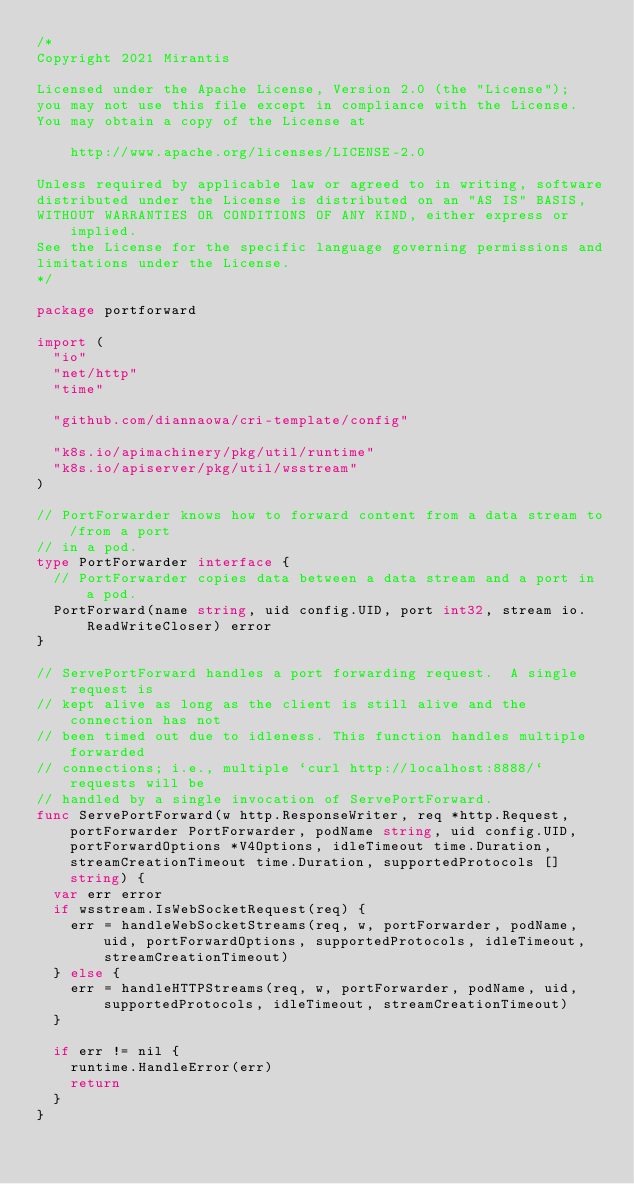Convert code to text. <code><loc_0><loc_0><loc_500><loc_500><_Go_>/*
Copyright 2021 Mirantis

Licensed under the Apache License, Version 2.0 (the "License");
you may not use this file except in compliance with the License.
You may obtain a copy of the License at

    http://www.apache.org/licenses/LICENSE-2.0

Unless required by applicable law or agreed to in writing, software
distributed under the License is distributed on an "AS IS" BASIS,
WITHOUT WARRANTIES OR CONDITIONS OF ANY KIND, either express or implied.
See the License for the specific language governing permissions and
limitations under the License.
*/

package portforward

import (
	"io"
	"net/http"
	"time"

	"github.com/diannaowa/cri-template/config"

	"k8s.io/apimachinery/pkg/util/runtime"
	"k8s.io/apiserver/pkg/util/wsstream"
)

// PortForwarder knows how to forward content from a data stream to/from a port
// in a pod.
type PortForwarder interface {
	// PortForwarder copies data between a data stream and a port in a pod.
	PortForward(name string, uid config.UID, port int32, stream io.ReadWriteCloser) error
}

// ServePortForward handles a port forwarding request.  A single request is
// kept alive as long as the client is still alive and the connection has not
// been timed out due to idleness. This function handles multiple forwarded
// connections; i.e., multiple `curl http://localhost:8888/` requests will be
// handled by a single invocation of ServePortForward.
func ServePortForward(w http.ResponseWriter, req *http.Request, portForwarder PortForwarder, podName string, uid config.UID, portForwardOptions *V4Options, idleTimeout time.Duration, streamCreationTimeout time.Duration, supportedProtocols []string) {
	var err error
	if wsstream.IsWebSocketRequest(req) {
		err = handleWebSocketStreams(req, w, portForwarder, podName, uid, portForwardOptions, supportedProtocols, idleTimeout, streamCreationTimeout)
	} else {
		err = handleHTTPStreams(req, w, portForwarder, podName, uid, supportedProtocols, idleTimeout, streamCreationTimeout)
	}

	if err != nil {
		runtime.HandleError(err)
		return
	}
}
</code> 